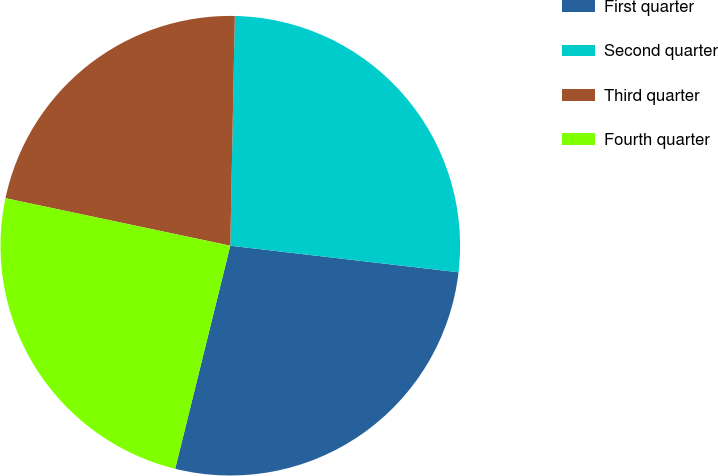Convert chart to OTSL. <chart><loc_0><loc_0><loc_500><loc_500><pie_chart><fcel>First quarter<fcel>Second quarter<fcel>Third quarter<fcel>Fourth quarter<nl><fcel>27.01%<fcel>26.53%<fcel>22.0%<fcel>24.46%<nl></chart> 